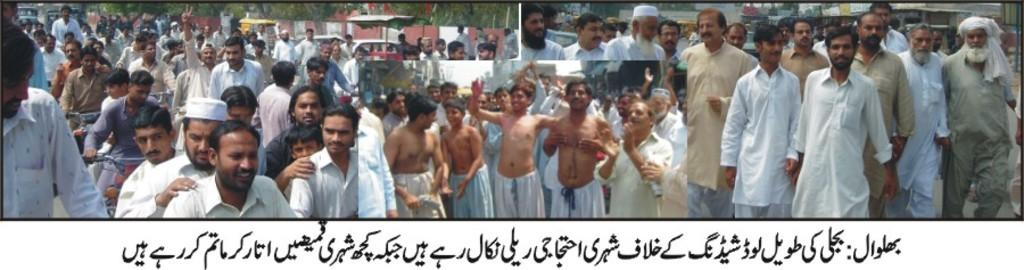What can be found at the bottom of the image? There is text at the bottom of the image. What is the main subject in the middle of the image? There is a group of people in the middle of the image. How would you describe the composition of the image? The image appears to be a photo collage. How many brothers are present in the image? There is no information about brothers in the image, as it features a group of people without specifying their relationships. 